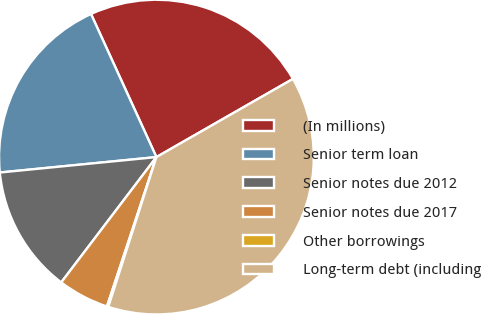Convert chart. <chart><loc_0><loc_0><loc_500><loc_500><pie_chart><fcel>(In millions)<fcel>Senior term loan<fcel>Senior notes due 2012<fcel>Senior notes due 2017<fcel>Other borrowings<fcel>Long-term debt (including<nl><fcel>23.55%<fcel>19.74%<fcel>13.1%<fcel>5.25%<fcel>0.14%<fcel>38.23%<nl></chart> 